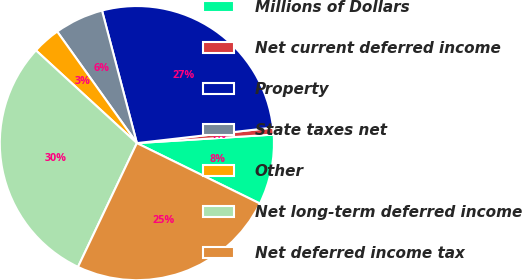Convert chart. <chart><loc_0><loc_0><loc_500><loc_500><pie_chart><fcel>Millions of Dollars<fcel>Net current deferred income<fcel>Property<fcel>State taxes net<fcel>Other<fcel>Net long-term deferred income<fcel>Net deferred income tax<nl><fcel>8.26%<fcel>0.82%<fcel>27.28%<fcel>5.78%<fcel>3.3%<fcel>29.76%<fcel>24.8%<nl></chart> 